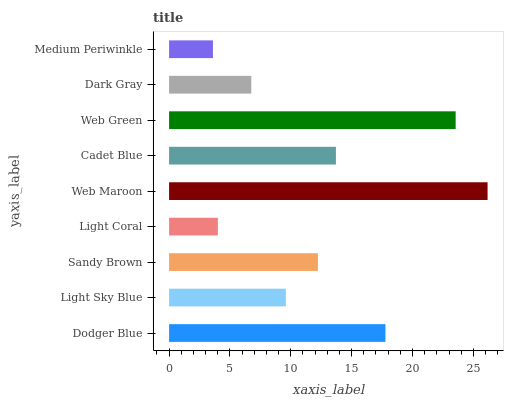Is Medium Periwinkle the minimum?
Answer yes or no. Yes. Is Web Maroon the maximum?
Answer yes or no. Yes. Is Light Sky Blue the minimum?
Answer yes or no. No. Is Light Sky Blue the maximum?
Answer yes or no. No. Is Dodger Blue greater than Light Sky Blue?
Answer yes or no. Yes. Is Light Sky Blue less than Dodger Blue?
Answer yes or no. Yes. Is Light Sky Blue greater than Dodger Blue?
Answer yes or no. No. Is Dodger Blue less than Light Sky Blue?
Answer yes or no. No. Is Sandy Brown the high median?
Answer yes or no. Yes. Is Sandy Brown the low median?
Answer yes or no. Yes. Is Medium Periwinkle the high median?
Answer yes or no. No. Is Light Coral the low median?
Answer yes or no. No. 